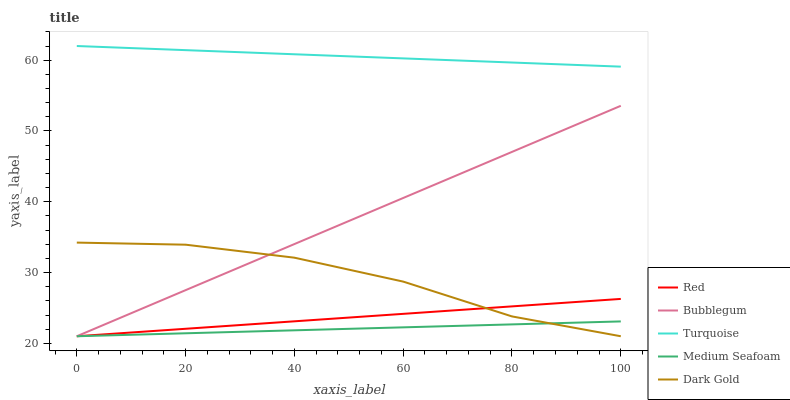Does Medium Seafoam have the minimum area under the curve?
Answer yes or no. Yes. Does Turquoise have the maximum area under the curve?
Answer yes or no. Yes. Does Dark Gold have the minimum area under the curve?
Answer yes or no. No. Does Dark Gold have the maximum area under the curve?
Answer yes or no. No. Is Red the smoothest?
Answer yes or no. Yes. Is Dark Gold the roughest?
Answer yes or no. Yes. Is Bubblegum the smoothest?
Answer yes or no. No. Is Bubblegum the roughest?
Answer yes or no. No. Does Dark Gold have the lowest value?
Answer yes or no. Yes. Does Turquoise have the highest value?
Answer yes or no. Yes. Does Dark Gold have the highest value?
Answer yes or no. No. Is Bubblegum less than Turquoise?
Answer yes or no. Yes. Is Turquoise greater than Medium Seafoam?
Answer yes or no. Yes. Does Bubblegum intersect Red?
Answer yes or no. Yes. Is Bubblegum less than Red?
Answer yes or no. No. Is Bubblegum greater than Red?
Answer yes or no. No. Does Bubblegum intersect Turquoise?
Answer yes or no. No. 